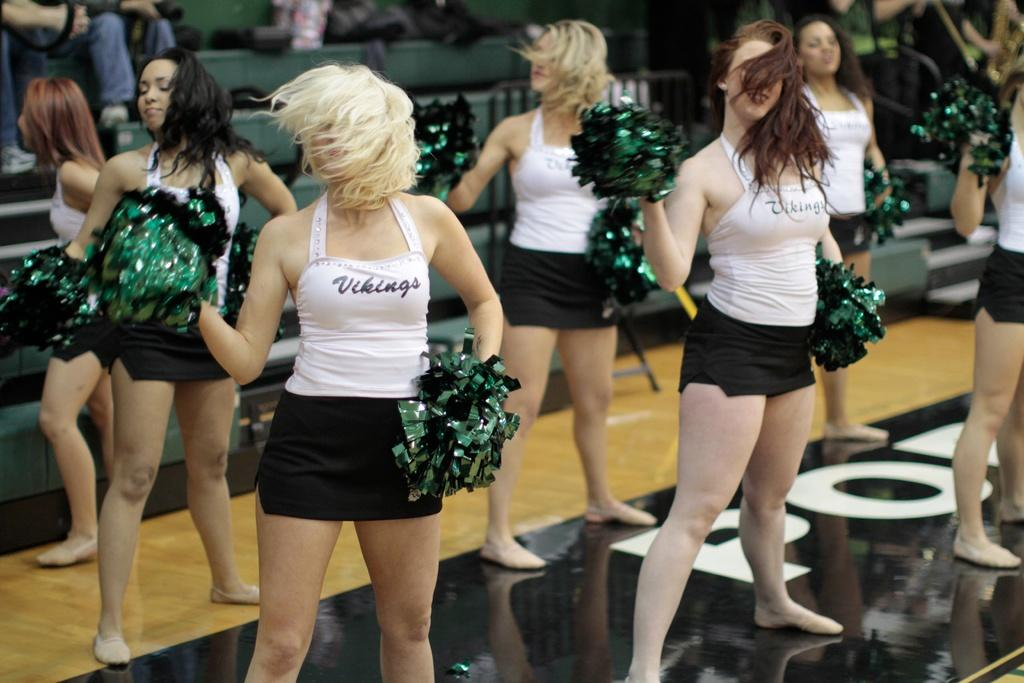Provide a one-sentence caption for the provided image. Cheerleaders for the vikings perform on the court. 